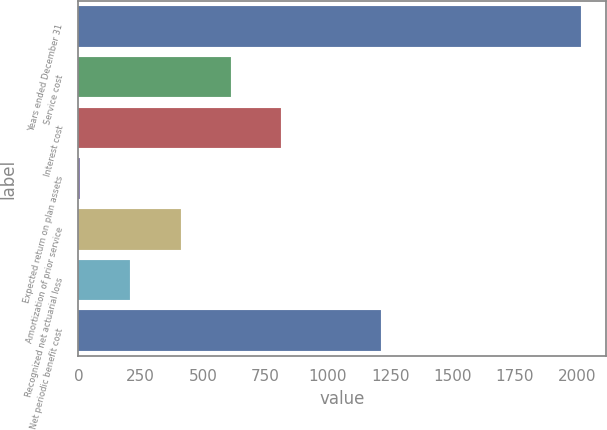Convert chart to OTSL. <chart><loc_0><loc_0><loc_500><loc_500><bar_chart><fcel>Years ended December 31<fcel>Service cost<fcel>Interest cost<fcel>Expected return on plan assets<fcel>Amortization of prior service<fcel>Recognized net actuarial loss<fcel>Net periodic benefit cost<nl><fcel>2015<fcel>610.1<fcel>810.8<fcel>8<fcel>409.4<fcel>208.7<fcel>1212.2<nl></chart> 